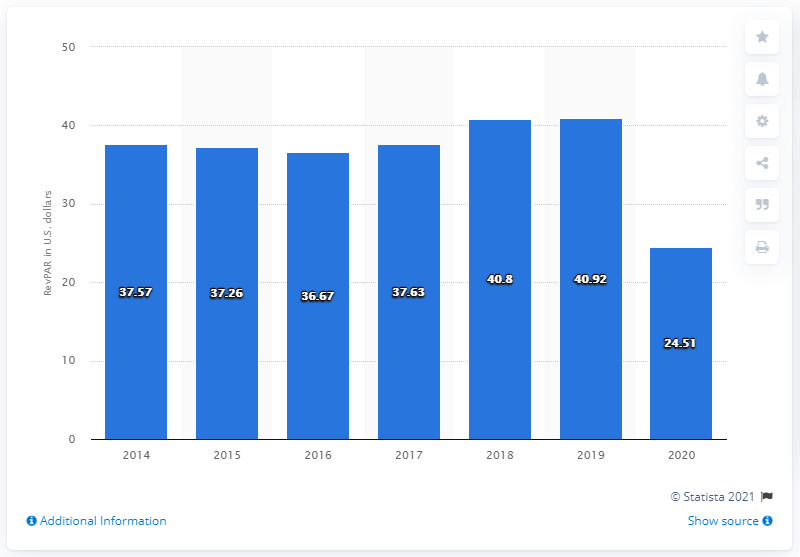Point out several critical features in this image. In 2020, the average revenue per available room (RevPAR) of Wyndham Hotels & Resorts Inc. hotels worldwide was 24.51. In 2020, the revenue per available room (RevPAR) of Wyndham Hotels & Resorts Inc. was 40.92 U.S. dollars. 